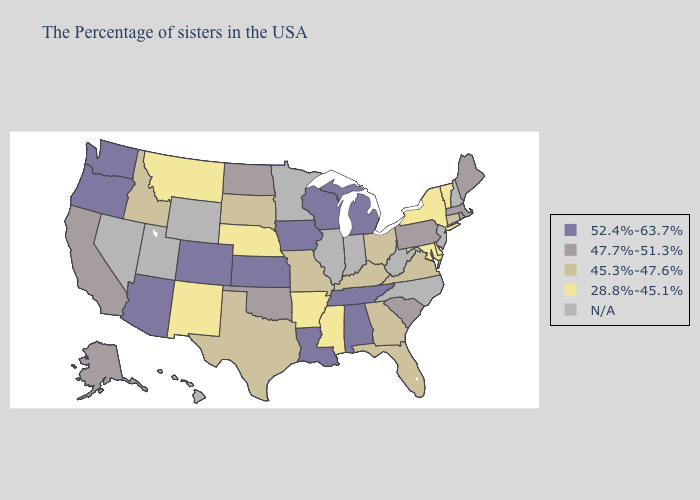What is the value of California?
Answer briefly. 47.7%-51.3%. What is the lowest value in states that border Indiana?
Concise answer only. 45.3%-47.6%. Among the states that border Georgia , which have the lowest value?
Give a very brief answer. Florida. What is the lowest value in the Northeast?
Quick response, please. 28.8%-45.1%. Does Ohio have the lowest value in the USA?
Keep it brief. No. What is the value of Mississippi?
Give a very brief answer. 28.8%-45.1%. Name the states that have a value in the range 52.4%-63.7%?
Short answer required. Michigan, Alabama, Tennessee, Wisconsin, Louisiana, Iowa, Kansas, Colorado, Arizona, Washington, Oregon. Does Vermont have the highest value in the Northeast?
Be succinct. No. Is the legend a continuous bar?
Answer briefly. No. Which states have the lowest value in the Northeast?
Write a very short answer. Vermont, New York. Name the states that have a value in the range 45.3%-47.6%?
Give a very brief answer. Connecticut, Virginia, Ohio, Florida, Georgia, Kentucky, Missouri, Texas, South Dakota, Idaho. What is the lowest value in the South?
Be succinct. 28.8%-45.1%. Name the states that have a value in the range 47.7%-51.3%?
Short answer required. Maine, Massachusetts, Rhode Island, Pennsylvania, South Carolina, Oklahoma, North Dakota, California, Alaska. What is the highest value in the Northeast ?
Short answer required. 47.7%-51.3%. 